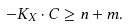<formula> <loc_0><loc_0><loc_500><loc_500>- K _ { X } \cdot C \geq n + m .</formula> 